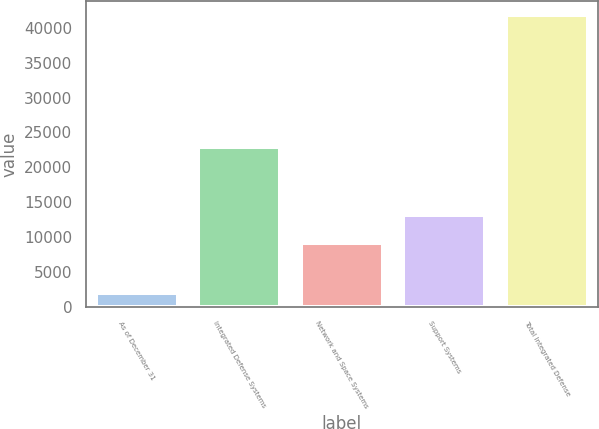Convert chart to OTSL. <chart><loc_0><loc_0><loc_500><loc_500><bar_chart><fcel>As of December 31<fcel>Integrated Defense Systems<fcel>Network and Space Systems<fcel>Support Systems<fcel>Total Integrated Defense<nl><fcel>2007<fcel>22957<fcel>9167<fcel>13145.1<fcel>41788<nl></chart> 